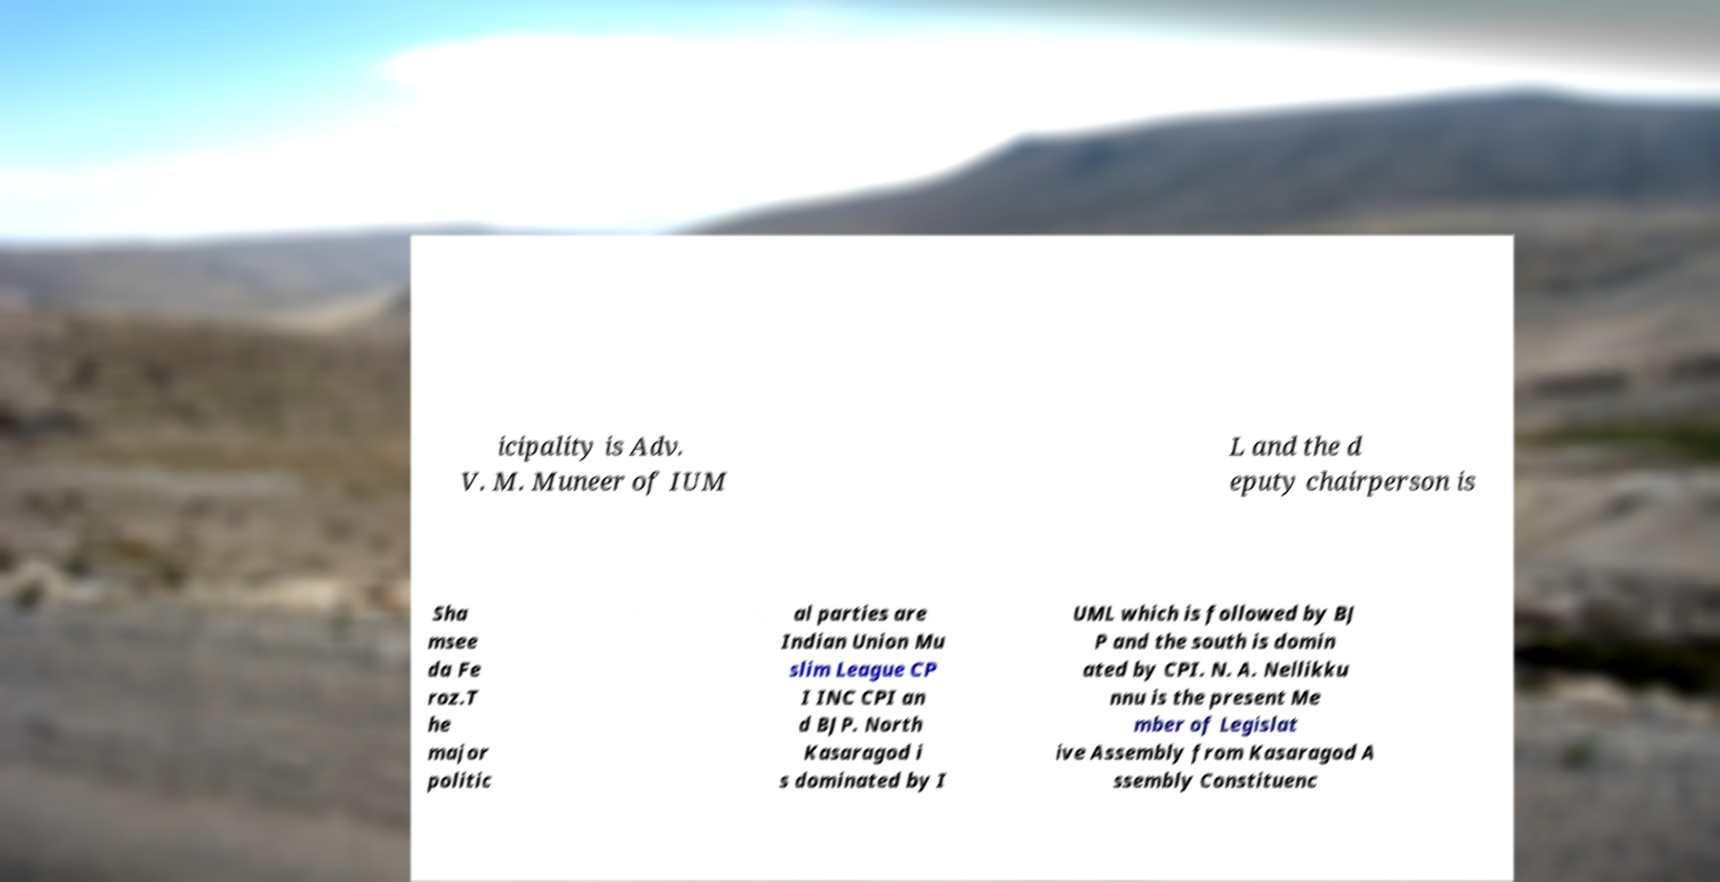I need the written content from this picture converted into text. Can you do that? icipality is Adv. V. M. Muneer of IUM L and the d eputy chairperson is Sha msee da Fe roz.T he major politic al parties are Indian Union Mu slim League CP I INC CPI an d BJP. North Kasaragod i s dominated by I UML which is followed by BJ P and the south is domin ated by CPI. N. A. Nellikku nnu is the present Me mber of Legislat ive Assembly from Kasaragod A ssembly Constituenc 